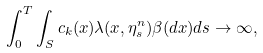Convert formula to latex. <formula><loc_0><loc_0><loc_500><loc_500>\int _ { 0 } ^ { T } \int _ { S } c _ { k } ( x ) \lambda ( x , \eta ^ { n } _ { s } ) \beta ( d x ) d s \rightarrow \infty ,</formula> 